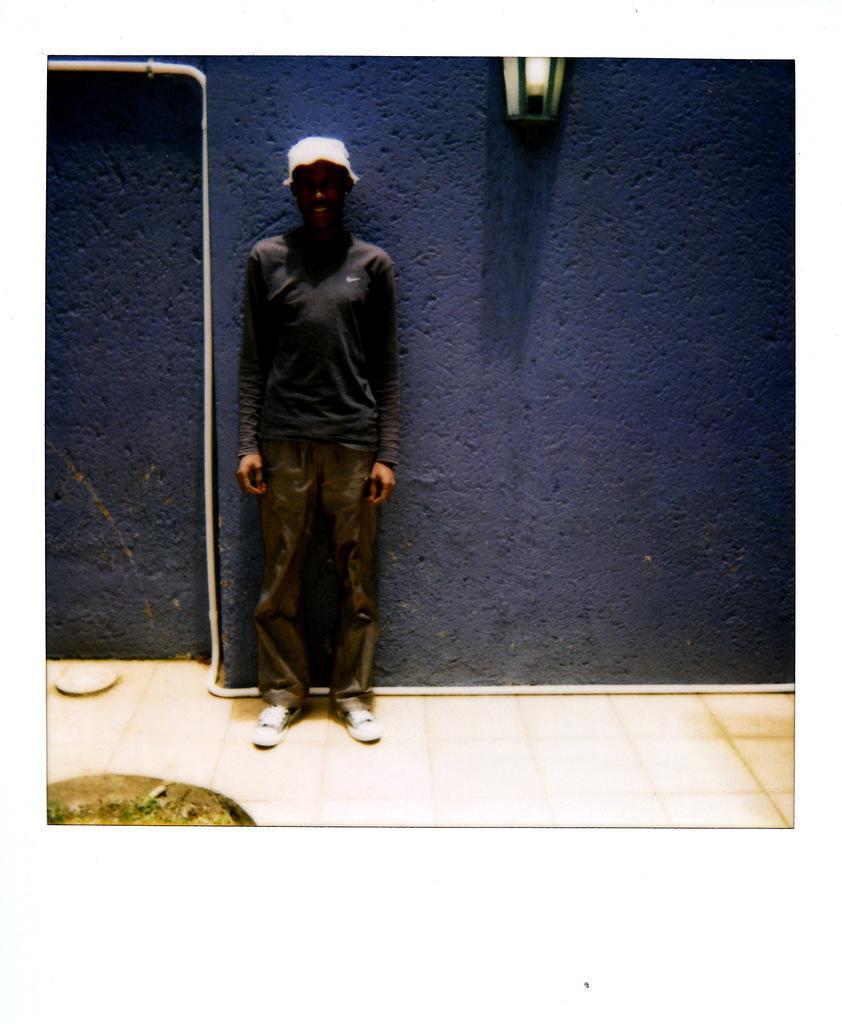Could you give a brief overview of what you see in this image? In the center of the image we can see one person is standing and he is smiling and we can see he is wearing a hat. At the bottom left side of the image we can see some object. In the background there is a wall, pipe, lamp, plate and a few other objects. 